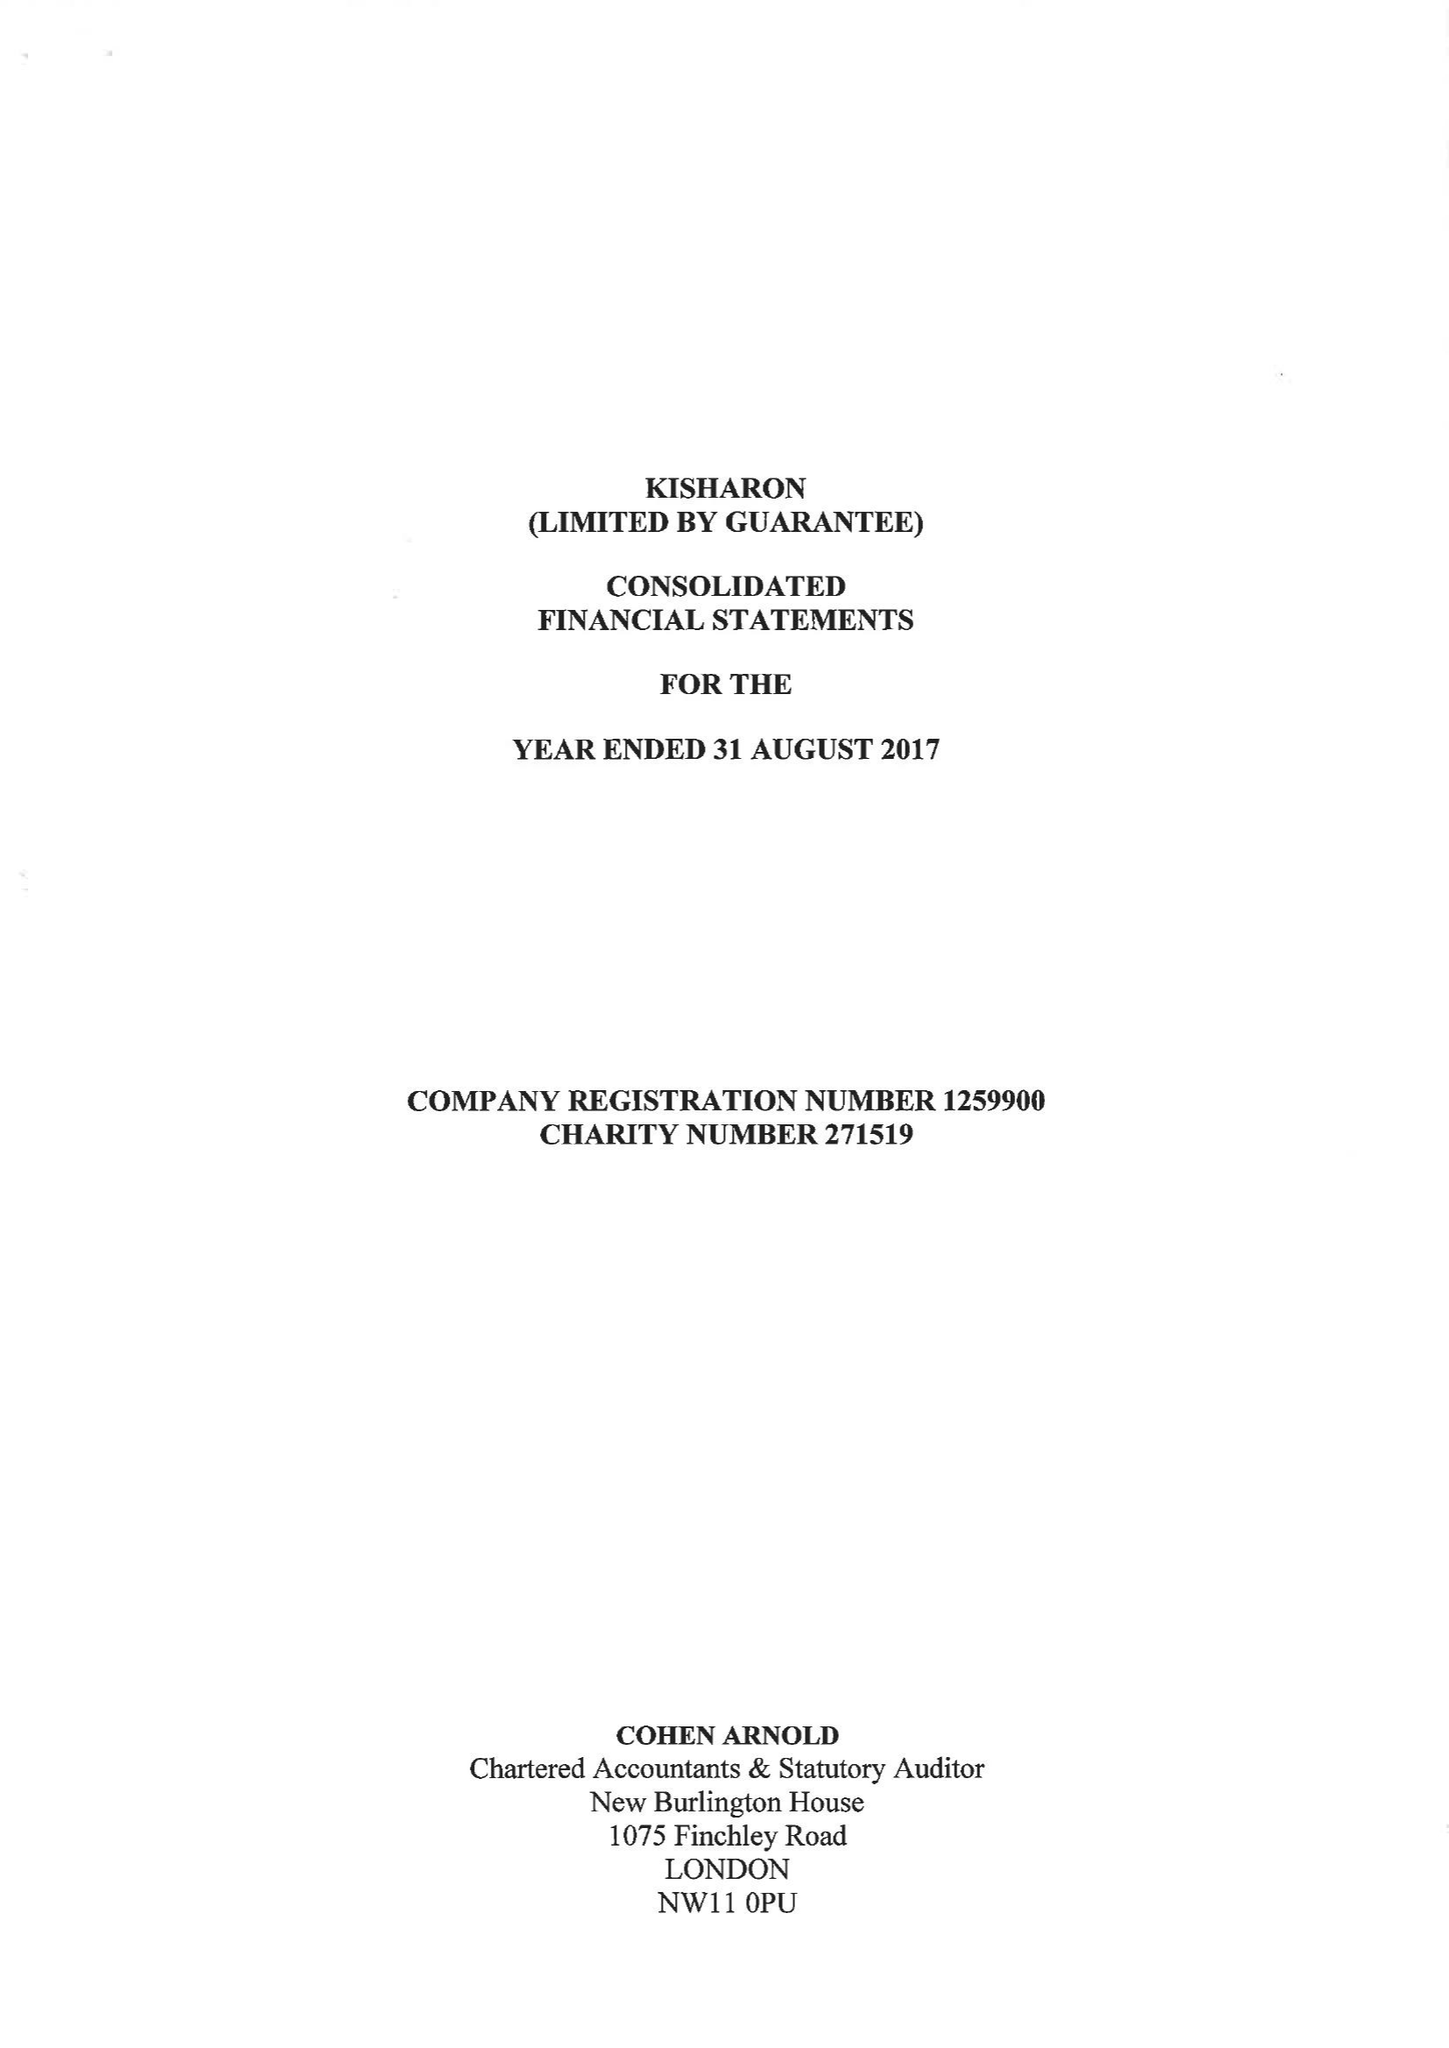What is the value for the charity_number?
Answer the question using a single word or phrase. 271519 